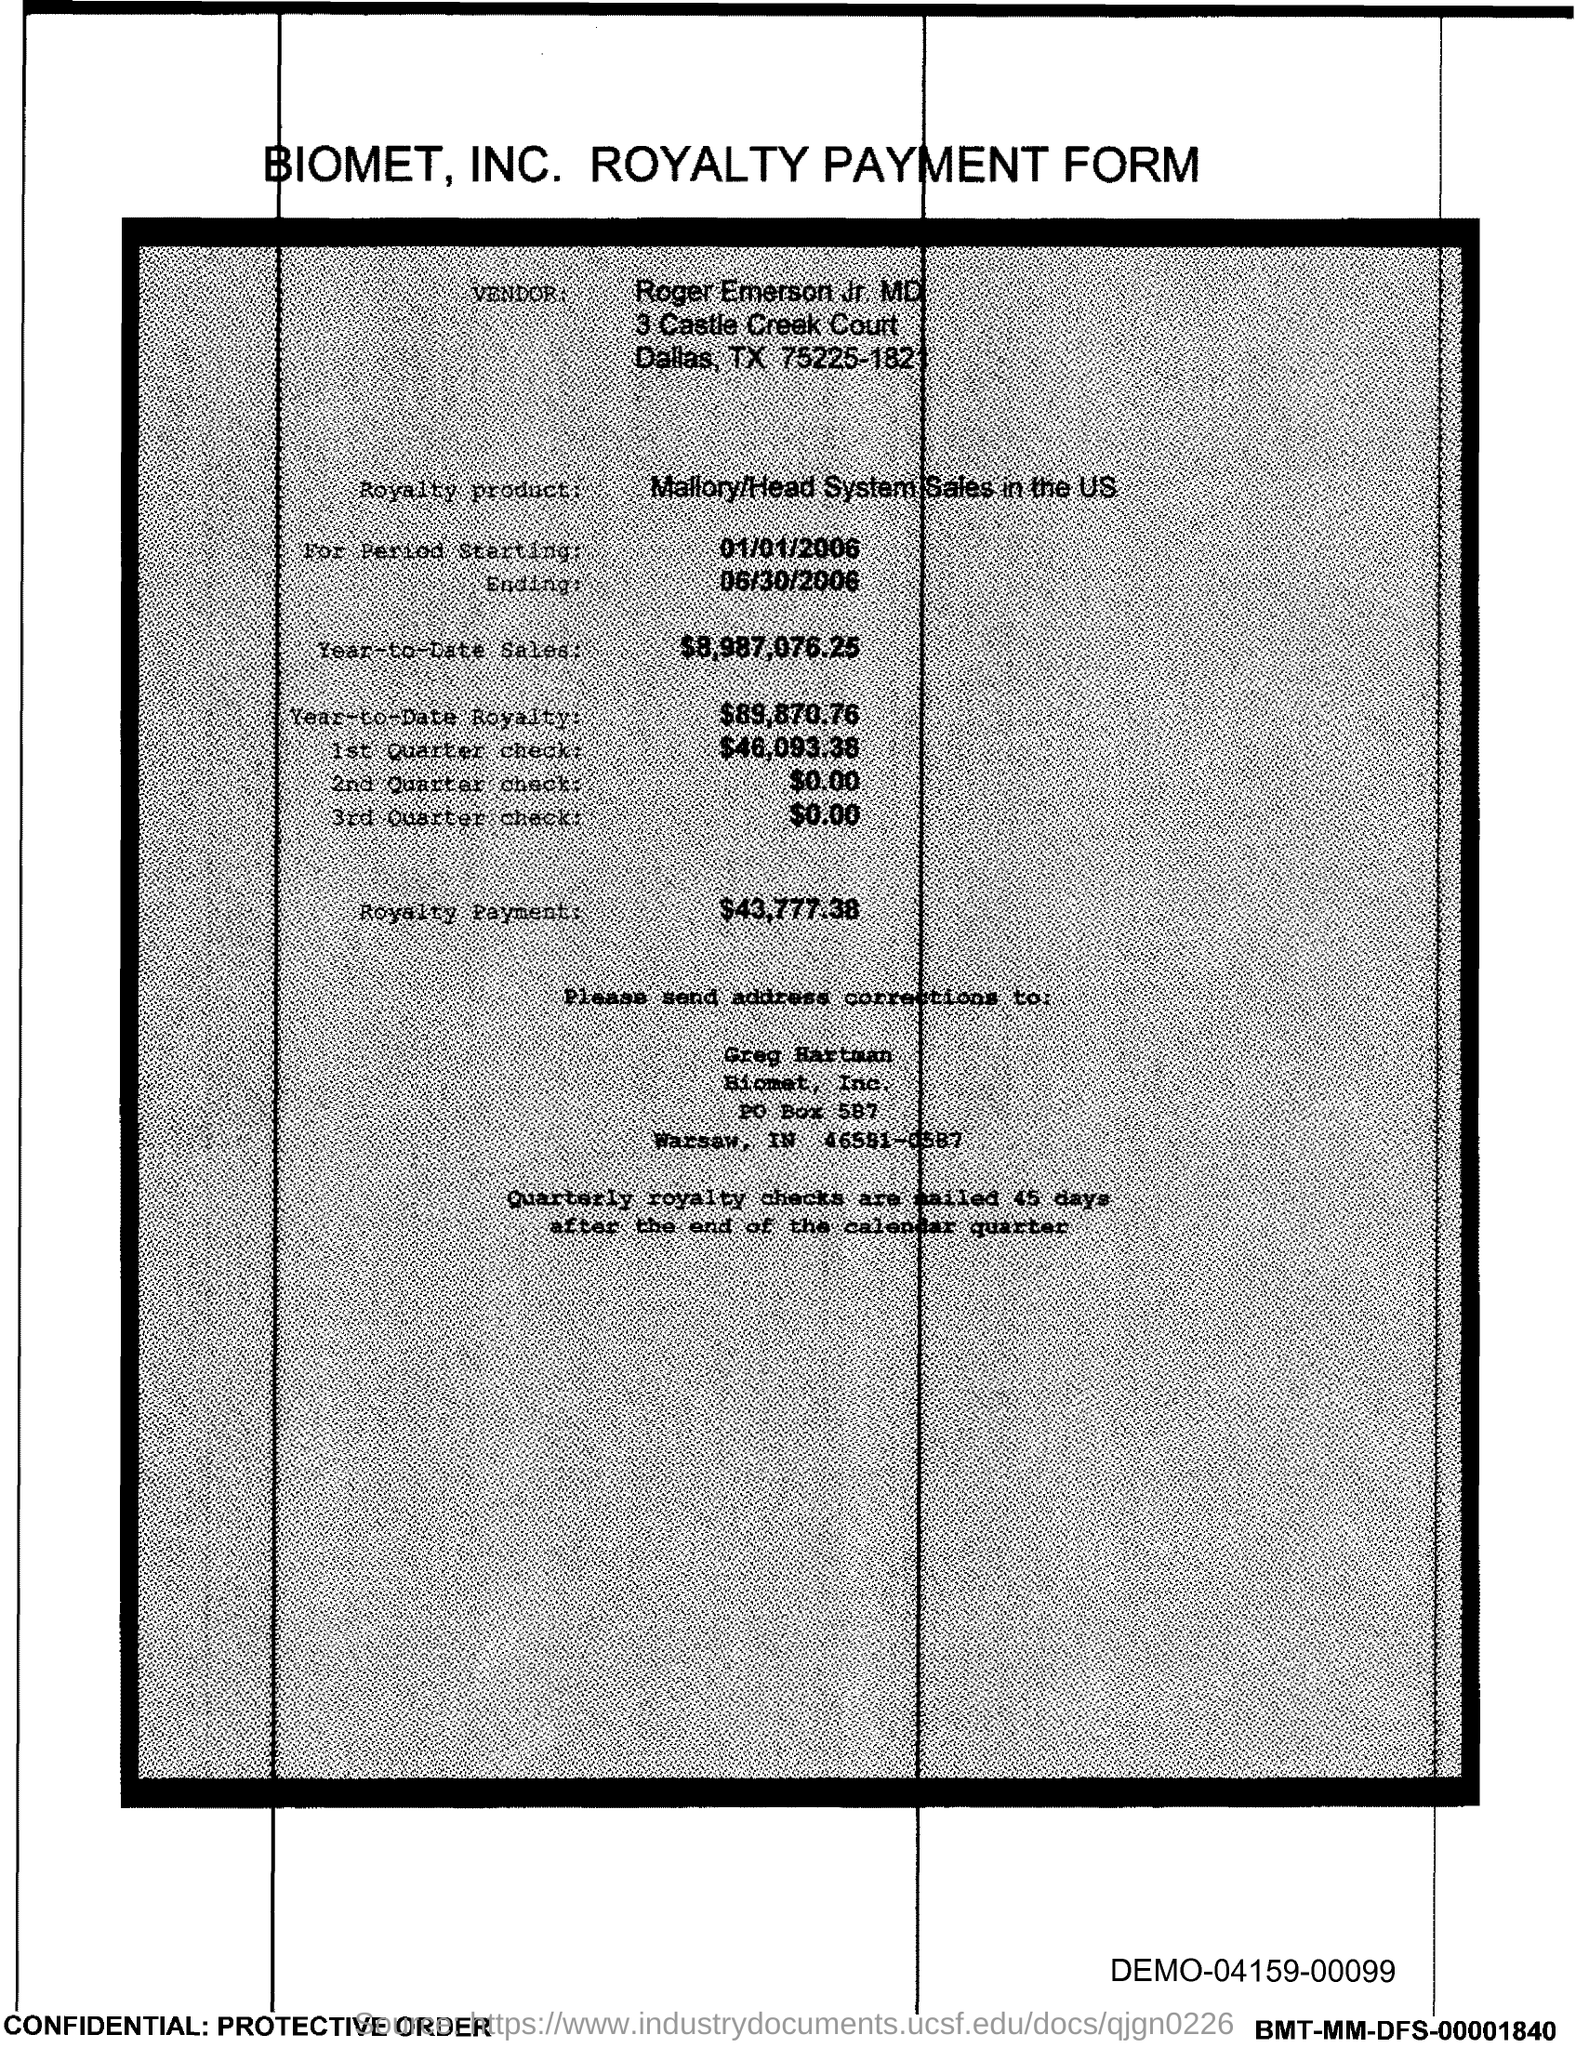Draw attention to some important aspects in this diagram. Greg Hartman is responsible for address corrections. The start date of the royalty period is January 1, 2006. The third quarter check amount given in the form is $0.00. The year-to-date sales of the royalty product are $8,987,076.25. The amount of the 1st quarter check mentioned in the form is $46,093.38. 